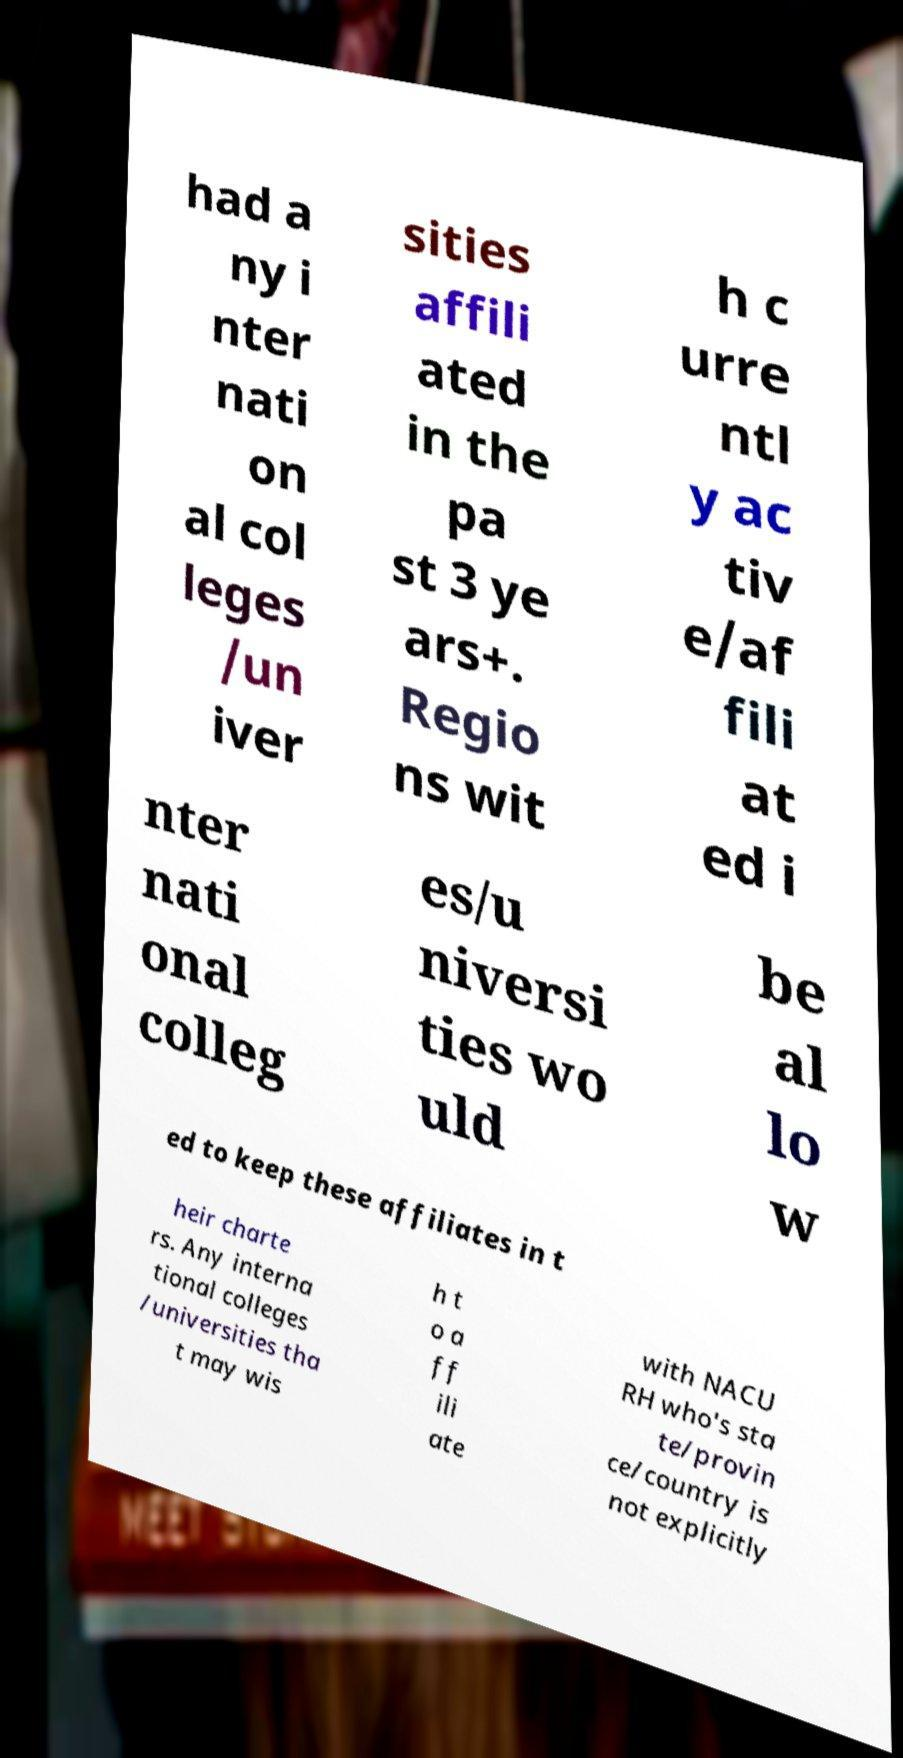I need the written content from this picture converted into text. Can you do that? had a ny i nter nati on al col leges /un iver sities affili ated in the pa st 3 ye ars+. Regio ns wit h c urre ntl y ac tiv e/af fili at ed i nter nati onal colleg es/u niversi ties wo uld be al lo w ed to keep these affiliates in t heir charte rs. Any interna tional colleges /universities tha t may wis h t o a ff ili ate with NACU RH who's sta te/provin ce/country is not explicitly 